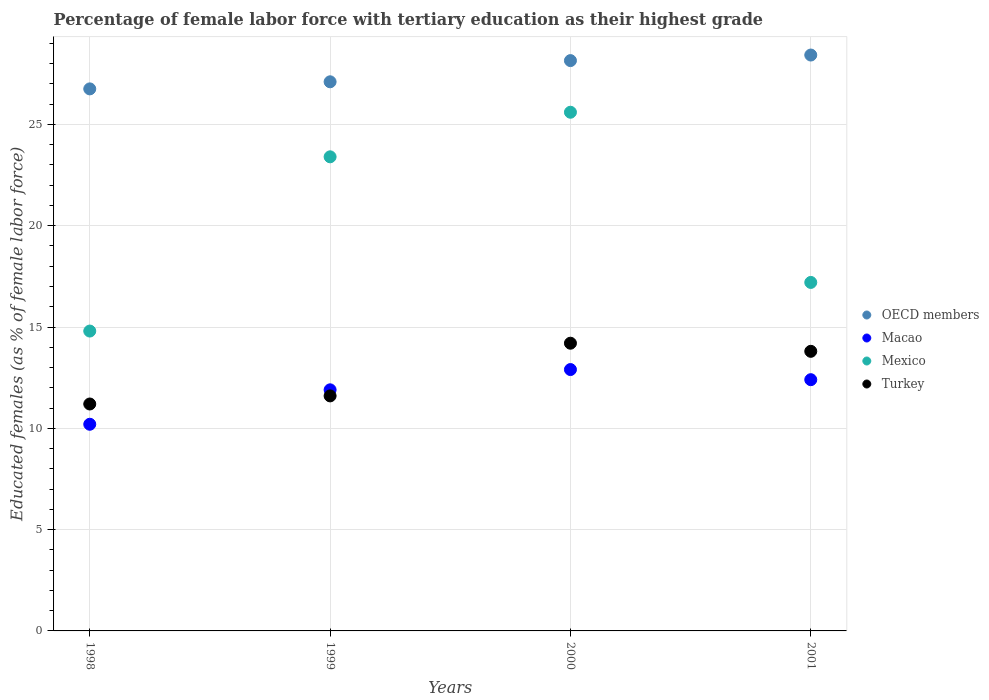Is the number of dotlines equal to the number of legend labels?
Your answer should be compact. Yes. What is the percentage of female labor force with tertiary education in Mexico in 1999?
Keep it short and to the point. 23.4. Across all years, what is the maximum percentage of female labor force with tertiary education in Mexico?
Give a very brief answer. 25.6. Across all years, what is the minimum percentage of female labor force with tertiary education in Macao?
Provide a short and direct response. 10.2. In which year was the percentage of female labor force with tertiary education in Turkey maximum?
Give a very brief answer. 2000. What is the total percentage of female labor force with tertiary education in Mexico in the graph?
Your answer should be compact. 81. What is the difference between the percentage of female labor force with tertiary education in Turkey in 1999 and that in 2001?
Give a very brief answer. -2.2. What is the difference between the percentage of female labor force with tertiary education in Mexico in 1998 and the percentage of female labor force with tertiary education in Macao in 2000?
Your answer should be very brief. 1.9. What is the average percentage of female labor force with tertiary education in OECD members per year?
Give a very brief answer. 27.61. In the year 1999, what is the difference between the percentage of female labor force with tertiary education in Mexico and percentage of female labor force with tertiary education in OECD members?
Give a very brief answer. -3.7. What is the ratio of the percentage of female labor force with tertiary education in Macao in 1999 to that in 2000?
Provide a succinct answer. 0.92. Is the percentage of female labor force with tertiary education in Macao in 1998 less than that in 2000?
Provide a succinct answer. Yes. What is the difference between the highest and the second highest percentage of female labor force with tertiary education in OECD members?
Provide a succinct answer. 0.28. What is the difference between the highest and the lowest percentage of female labor force with tertiary education in OECD members?
Your response must be concise. 1.67. In how many years, is the percentage of female labor force with tertiary education in Macao greater than the average percentage of female labor force with tertiary education in Macao taken over all years?
Offer a terse response. 3. Is it the case that in every year, the sum of the percentage of female labor force with tertiary education in OECD members and percentage of female labor force with tertiary education in Macao  is greater than the percentage of female labor force with tertiary education in Mexico?
Give a very brief answer. Yes. Is the percentage of female labor force with tertiary education in Macao strictly less than the percentage of female labor force with tertiary education in Mexico over the years?
Provide a short and direct response. Yes. How many years are there in the graph?
Provide a succinct answer. 4. What is the difference between two consecutive major ticks on the Y-axis?
Keep it short and to the point. 5. Does the graph contain grids?
Keep it short and to the point. Yes. How many legend labels are there?
Provide a succinct answer. 4. What is the title of the graph?
Keep it short and to the point. Percentage of female labor force with tertiary education as their highest grade. What is the label or title of the Y-axis?
Your answer should be very brief. Educated females (as % of female labor force). What is the Educated females (as % of female labor force) of OECD members in 1998?
Ensure brevity in your answer.  26.75. What is the Educated females (as % of female labor force) in Macao in 1998?
Ensure brevity in your answer.  10.2. What is the Educated females (as % of female labor force) of Mexico in 1998?
Your response must be concise. 14.8. What is the Educated females (as % of female labor force) of Turkey in 1998?
Ensure brevity in your answer.  11.2. What is the Educated females (as % of female labor force) in OECD members in 1999?
Make the answer very short. 27.1. What is the Educated females (as % of female labor force) in Macao in 1999?
Give a very brief answer. 11.9. What is the Educated females (as % of female labor force) in Mexico in 1999?
Your answer should be very brief. 23.4. What is the Educated females (as % of female labor force) of Turkey in 1999?
Your answer should be compact. 11.6. What is the Educated females (as % of female labor force) of OECD members in 2000?
Offer a terse response. 28.15. What is the Educated females (as % of female labor force) of Macao in 2000?
Ensure brevity in your answer.  12.9. What is the Educated females (as % of female labor force) of Mexico in 2000?
Provide a succinct answer. 25.6. What is the Educated females (as % of female labor force) of Turkey in 2000?
Ensure brevity in your answer.  14.2. What is the Educated females (as % of female labor force) of OECD members in 2001?
Give a very brief answer. 28.42. What is the Educated females (as % of female labor force) of Macao in 2001?
Your response must be concise. 12.4. What is the Educated females (as % of female labor force) in Mexico in 2001?
Your response must be concise. 17.2. What is the Educated females (as % of female labor force) in Turkey in 2001?
Your response must be concise. 13.8. Across all years, what is the maximum Educated females (as % of female labor force) of OECD members?
Make the answer very short. 28.42. Across all years, what is the maximum Educated females (as % of female labor force) in Macao?
Keep it short and to the point. 12.9. Across all years, what is the maximum Educated females (as % of female labor force) of Mexico?
Keep it short and to the point. 25.6. Across all years, what is the maximum Educated females (as % of female labor force) of Turkey?
Your answer should be very brief. 14.2. Across all years, what is the minimum Educated females (as % of female labor force) in OECD members?
Provide a short and direct response. 26.75. Across all years, what is the minimum Educated females (as % of female labor force) in Macao?
Your answer should be compact. 10.2. Across all years, what is the minimum Educated females (as % of female labor force) in Mexico?
Make the answer very short. 14.8. Across all years, what is the minimum Educated females (as % of female labor force) in Turkey?
Keep it short and to the point. 11.2. What is the total Educated females (as % of female labor force) in OECD members in the graph?
Offer a terse response. 110.43. What is the total Educated females (as % of female labor force) in Macao in the graph?
Keep it short and to the point. 47.4. What is the total Educated females (as % of female labor force) in Mexico in the graph?
Ensure brevity in your answer.  81. What is the total Educated females (as % of female labor force) of Turkey in the graph?
Make the answer very short. 50.8. What is the difference between the Educated females (as % of female labor force) of OECD members in 1998 and that in 1999?
Your answer should be compact. -0.35. What is the difference between the Educated females (as % of female labor force) in Macao in 1998 and that in 1999?
Offer a terse response. -1.7. What is the difference between the Educated females (as % of female labor force) in Turkey in 1998 and that in 1999?
Keep it short and to the point. -0.4. What is the difference between the Educated females (as % of female labor force) in OECD members in 1998 and that in 2000?
Provide a succinct answer. -1.4. What is the difference between the Educated females (as % of female labor force) in OECD members in 1998 and that in 2001?
Your answer should be compact. -1.67. What is the difference between the Educated females (as % of female labor force) of Mexico in 1998 and that in 2001?
Your answer should be very brief. -2.4. What is the difference between the Educated females (as % of female labor force) in OECD members in 1999 and that in 2000?
Ensure brevity in your answer.  -1.05. What is the difference between the Educated females (as % of female labor force) in OECD members in 1999 and that in 2001?
Your answer should be very brief. -1.32. What is the difference between the Educated females (as % of female labor force) in Macao in 1999 and that in 2001?
Ensure brevity in your answer.  -0.5. What is the difference between the Educated females (as % of female labor force) in Mexico in 1999 and that in 2001?
Give a very brief answer. 6.2. What is the difference between the Educated females (as % of female labor force) in OECD members in 2000 and that in 2001?
Offer a terse response. -0.28. What is the difference between the Educated females (as % of female labor force) in Turkey in 2000 and that in 2001?
Keep it short and to the point. 0.4. What is the difference between the Educated females (as % of female labor force) of OECD members in 1998 and the Educated females (as % of female labor force) of Macao in 1999?
Offer a very short reply. 14.85. What is the difference between the Educated females (as % of female labor force) of OECD members in 1998 and the Educated females (as % of female labor force) of Mexico in 1999?
Provide a short and direct response. 3.35. What is the difference between the Educated females (as % of female labor force) of OECD members in 1998 and the Educated females (as % of female labor force) of Turkey in 1999?
Ensure brevity in your answer.  15.15. What is the difference between the Educated females (as % of female labor force) of OECD members in 1998 and the Educated females (as % of female labor force) of Macao in 2000?
Your answer should be compact. 13.85. What is the difference between the Educated females (as % of female labor force) of OECD members in 1998 and the Educated females (as % of female labor force) of Mexico in 2000?
Offer a very short reply. 1.15. What is the difference between the Educated females (as % of female labor force) of OECD members in 1998 and the Educated females (as % of female labor force) of Turkey in 2000?
Provide a short and direct response. 12.55. What is the difference between the Educated females (as % of female labor force) of Macao in 1998 and the Educated females (as % of female labor force) of Mexico in 2000?
Make the answer very short. -15.4. What is the difference between the Educated females (as % of female labor force) of OECD members in 1998 and the Educated females (as % of female labor force) of Macao in 2001?
Provide a short and direct response. 14.35. What is the difference between the Educated females (as % of female labor force) of OECD members in 1998 and the Educated females (as % of female labor force) of Mexico in 2001?
Provide a short and direct response. 9.55. What is the difference between the Educated females (as % of female labor force) of OECD members in 1998 and the Educated females (as % of female labor force) of Turkey in 2001?
Your answer should be very brief. 12.95. What is the difference between the Educated females (as % of female labor force) in Macao in 1998 and the Educated females (as % of female labor force) in Turkey in 2001?
Offer a very short reply. -3.6. What is the difference between the Educated females (as % of female labor force) in Mexico in 1998 and the Educated females (as % of female labor force) in Turkey in 2001?
Provide a short and direct response. 1. What is the difference between the Educated females (as % of female labor force) in OECD members in 1999 and the Educated females (as % of female labor force) in Macao in 2000?
Give a very brief answer. 14.2. What is the difference between the Educated females (as % of female labor force) in OECD members in 1999 and the Educated females (as % of female labor force) in Mexico in 2000?
Provide a short and direct response. 1.5. What is the difference between the Educated females (as % of female labor force) of OECD members in 1999 and the Educated females (as % of female labor force) of Turkey in 2000?
Your response must be concise. 12.9. What is the difference between the Educated females (as % of female labor force) in Macao in 1999 and the Educated females (as % of female labor force) in Mexico in 2000?
Make the answer very short. -13.7. What is the difference between the Educated females (as % of female labor force) in Macao in 1999 and the Educated females (as % of female labor force) in Turkey in 2000?
Your answer should be compact. -2.3. What is the difference between the Educated females (as % of female labor force) in OECD members in 1999 and the Educated females (as % of female labor force) in Macao in 2001?
Your answer should be very brief. 14.7. What is the difference between the Educated females (as % of female labor force) in OECD members in 1999 and the Educated females (as % of female labor force) in Mexico in 2001?
Offer a very short reply. 9.9. What is the difference between the Educated females (as % of female labor force) in OECD members in 1999 and the Educated females (as % of female labor force) in Turkey in 2001?
Keep it short and to the point. 13.3. What is the difference between the Educated females (as % of female labor force) in Macao in 1999 and the Educated females (as % of female labor force) in Mexico in 2001?
Provide a succinct answer. -5.3. What is the difference between the Educated females (as % of female labor force) in Macao in 1999 and the Educated females (as % of female labor force) in Turkey in 2001?
Offer a terse response. -1.9. What is the difference between the Educated females (as % of female labor force) of OECD members in 2000 and the Educated females (as % of female labor force) of Macao in 2001?
Offer a terse response. 15.75. What is the difference between the Educated females (as % of female labor force) in OECD members in 2000 and the Educated females (as % of female labor force) in Mexico in 2001?
Offer a very short reply. 10.95. What is the difference between the Educated females (as % of female labor force) of OECD members in 2000 and the Educated females (as % of female labor force) of Turkey in 2001?
Your answer should be very brief. 14.35. What is the difference between the Educated females (as % of female labor force) in Macao in 2000 and the Educated females (as % of female labor force) in Mexico in 2001?
Give a very brief answer. -4.3. What is the average Educated females (as % of female labor force) of OECD members per year?
Your response must be concise. 27.61. What is the average Educated females (as % of female labor force) of Macao per year?
Ensure brevity in your answer.  11.85. What is the average Educated females (as % of female labor force) in Mexico per year?
Make the answer very short. 20.25. In the year 1998, what is the difference between the Educated females (as % of female labor force) in OECD members and Educated females (as % of female labor force) in Macao?
Give a very brief answer. 16.55. In the year 1998, what is the difference between the Educated females (as % of female labor force) of OECD members and Educated females (as % of female labor force) of Mexico?
Your answer should be compact. 11.95. In the year 1998, what is the difference between the Educated females (as % of female labor force) of OECD members and Educated females (as % of female labor force) of Turkey?
Keep it short and to the point. 15.55. In the year 1998, what is the difference between the Educated females (as % of female labor force) in Macao and Educated females (as % of female labor force) in Mexico?
Your answer should be compact. -4.6. In the year 1998, what is the difference between the Educated females (as % of female labor force) of Mexico and Educated females (as % of female labor force) of Turkey?
Provide a short and direct response. 3.6. In the year 1999, what is the difference between the Educated females (as % of female labor force) of OECD members and Educated females (as % of female labor force) of Macao?
Offer a terse response. 15.2. In the year 1999, what is the difference between the Educated females (as % of female labor force) of OECD members and Educated females (as % of female labor force) of Mexico?
Your response must be concise. 3.7. In the year 1999, what is the difference between the Educated females (as % of female labor force) in OECD members and Educated females (as % of female labor force) in Turkey?
Ensure brevity in your answer.  15.5. In the year 1999, what is the difference between the Educated females (as % of female labor force) in Macao and Educated females (as % of female labor force) in Mexico?
Keep it short and to the point. -11.5. In the year 1999, what is the difference between the Educated females (as % of female labor force) of Macao and Educated females (as % of female labor force) of Turkey?
Offer a terse response. 0.3. In the year 1999, what is the difference between the Educated females (as % of female labor force) of Mexico and Educated females (as % of female labor force) of Turkey?
Ensure brevity in your answer.  11.8. In the year 2000, what is the difference between the Educated females (as % of female labor force) of OECD members and Educated females (as % of female labor force) of Macao?
Give a very brief answer. 15.25. In the year 2000, what is the difference between the Educated females (as % of female labor force) of OECD members and Educated females (as % of female labor force) of Mexico?
Provide a short and direct response. 2.55. In the year 2000, what is the difference between the Educated females (as % of female labor force) in OECD members and Educated females (as % of female labor force) in Turkey?
Keep it short and to the point. 13.95. In the year 2000, what is the difference between the Educated females (as % of female labor force) in Macao and Educated females (as % of female labor force) in Turkey?
Make the answer very short. -1.3. In the year 2001, what is the difference between the Educated females (as % of female labor force) of OECD members and Educated females (as % of female labor force) of Macao?
Your answer should be very brief. 16.02. In the year 2001, what is the difference between the Educated females (as % of female labor force) of OECD members and Educated females (as % of female labor force) of Mexico?
Your answer should be very brief. 11.22. In the year 2001, what is the difference between the Educated females (as % of female labor force) in OECD members and Educated females (as % of female labor force) in Turkey?
Your response must be concise. 14.62. In the year 2001, what is the difference between the Educated females (as % of female labor force) in Macao and Educated females (as % of female labor force) in Mexico?
Provide a succinct answer. -4.8. In the year 2001, what is the difference between the Educated females (as % of female labor force) of Mexico and Educated females (as % of female labor force) of Turkey?
Provide a short and direct response. 3.4. What is the ratio of the Educated females (as % of female labor force) of OECD members in 1998 to that in 1999?
Offer a terse response. 0.99. What is the ratio of the Educated females (as % of female labor force) of Mexico in 1998 to that in 1999?
Provide a succinct answer. 0.63. What is the ratio of the Educated females (as % of female labor force) of Turkey in 1998 to that in 1999?
Give a very brief answer. 0.97. What is the ratio of the Educated females (as % of female labor force) of OECD members in 1998 to that in 2000?
Keep it short and to the point. 0.95. What is the ratio of the Educated females (as % of female labor force) of Macao in 1998 to that in 2000?
Your answer should be very brief. 0.79. What is the ratio of the Educated females (as % of female labor force) in Mexico in 1998 to that in 2000?
Offer a terse response. 0.58. What is the ratio of the Educated females (as % of female labor force) of Turkey in 1998 to that in 2000?
Your answer should be very brief. 0.79. What is the ratio of the Educated females (as % of female labor force) in Macao in 1998 to that in 2001?
Offer a terse response. 0.82. What is the ratio of the Educated females (as % of female labor force) in Mexico in 1998 to that in 2001?
Keep it short and to the point. 0.86. What is the ratio of the Educated females (as % of female labor force) of Turkey in 1998 to that in 2001?
Your answer should be very brief. 0.81. What is the ratio of the Educated females (as % of female labor force) in OECD members in 1999 to that in 2000?
Ensure brevity in your answer.  0.96. What is the ratio of the Educated females (as % of female labor force) of Macao in 1999 to that in 2000?
Provide a short and direct response. 0.92. What is the ratio of the Educated females (as % of female labor force) of Mexico in 1999 to that in 2000?
Ensure brevity in your answer.  0.91. What is the ratio of the Educated females (as % of female labor force) of Turkey in 1999 to that in 2000?
Your answer should be very brief. 0.82. What is the ratio of the Educated females (as % of female labor force) of OECD members in 1999 to that in 2001?
Ensure brevity in your answer.  0.95. What is the ratio of the Educated females (as % of female labor force) in Macao in 1999 to that in 2001?
Your answer should be very brief. 0.96. What is the ratio of the Educated females (as % of female labor force) in Mexico in 1999 to that in 2001?
Offer a very short reply. 1.36. What is the ratio of the Educated females (as % of female labor force) of Turkey in 1999 to that in 2001?
Provide a succinct answer. 0.84. What is the ratio of the Educated females (as % of female labor force) in OECD members in 2000 to that in 2001?
Offer a very short reply. 0.99. What is the ratio of the Educated females (as % of female labor force) of Macao in 2000 to that in 2001?
Keep it short and to the point. 1.04. What is the ratio of the Educated females (as % of female labor force) in Mexico in 2000 to that in 2001?
Ensure brevity in your answer.  1.49. What is the ratio of the Educated females (as % of female labor force) in Turkey in 2000 to that in 2001?
Your answer should be compact. 1.03. What is the difference between the highest and the second highest Educated females (as % of female labor force) of OECD members?
Ensure brevity in your answer.  0.28. What is the difference between the highest and the second highest Educated females (as % of female labor force) in Mexico?
Make the answer very short. 2.2. What is the difference between the highest and the lowest Educated females (as % of female labor force) in OECD members?
Make the answer very short. 1.67. What is the difference between the highest and the lowest Educated females (as % of female labor force) of Macao?
Offer a very short reply. 2.7. 